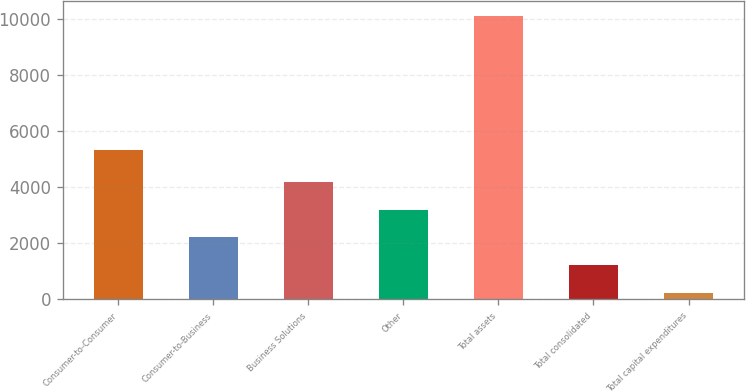Convert chart to OTSL. <chart><loc_0><loc_0><loc_500><loc_500><bar_chart><fcel>Consumer-to-Consumer<fcel>Consumer-to-Business<fcel>Business Solutions<fcel>Other<fcel>Total assets<fcel>Total consolidated<fcel>Total capital expenditures<nl><fcel>5321.9<fcel>2217.3<fcel>4193.3<fcel>3205.3<fcel>10121.3<fcel>1229.3<fcel>241.3<nl></chart> 